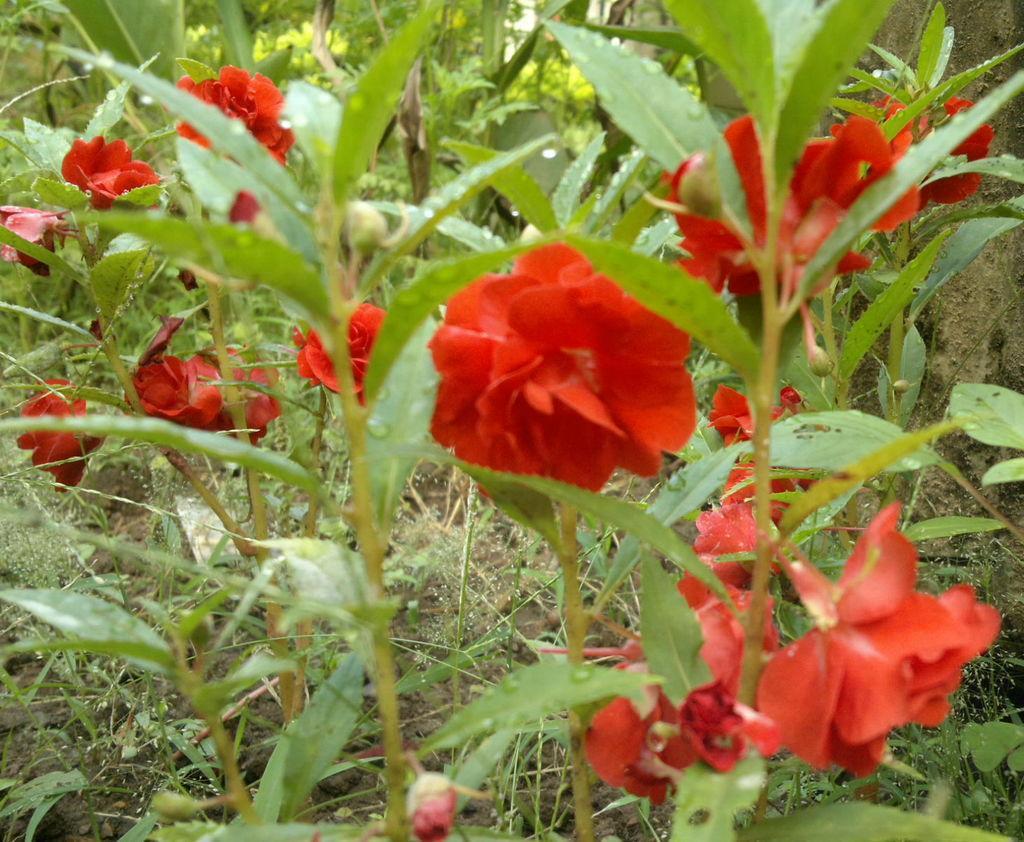Could you give a brief overview of what you see in this image? This image consists of flowers in red color along with the plants. At the bottom, we can see the grass. 